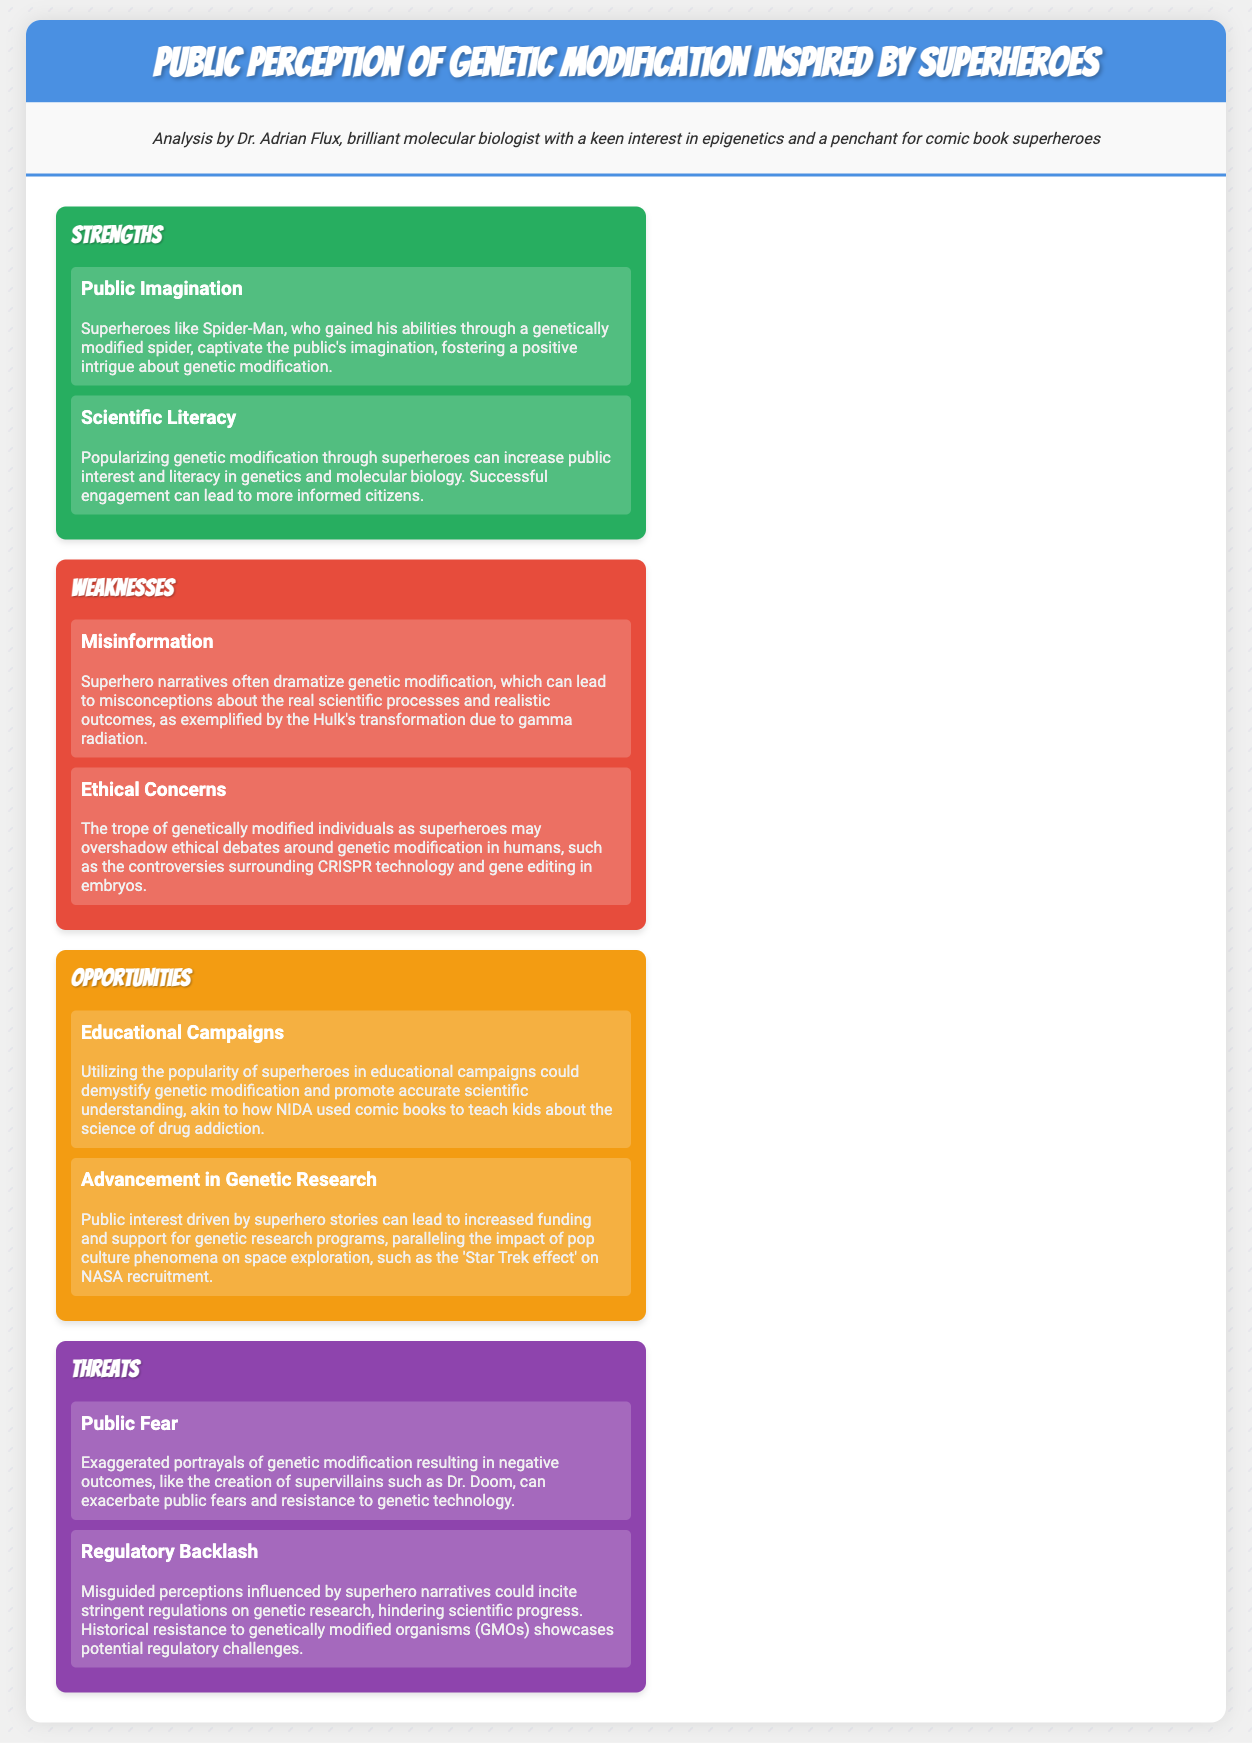What are the strengths highlighted in the analysis? The strengths are the aspects of the SWOT analysis that emphasize positive factors related to public perception of genetic modification. The document identifies "Public Imagination" and "Scientific Literacy" as strengths.
Answer: Public Imagination, Scientific Literacy What superhero is mentioned in the strengths section? The mention of Spider-Man in the strengths section highlights a superhero that influences public perception positively.
Answer: Spider-Man What are the weaknesses identified in the analysis? The weaknesses are detrimental aspects related to public perception of genetic modification. The document states "Misinformation" and "Ethical Concerns" as weaknesses.
Answer: Misinformation, Ethical Concerns What opportunity is suggested concerning educational campaigns? The document proposes that utilizing superhero popularity in campaigns could help clarify genetic modification. This is an example of the potential opportunities noted.
Answer: Educational Campaigns What threat is associated with public fear according to the analysis? The analysis suggests that exaggerated portrayals of genetic modification lead to public fears, which is a critical aspect of the threats identified.
Answer: Public Fear What does “Regulatory Backlash” refer to in the threats? This term in the document relates to misguided perceptions based on superhero narratives that could impact regulations on genetic research.
Answer: Regulatory Backlash How can superhero narratives impact funding for genetic research? The analysis notes that public interest from superhero stories could lead to increased funding and support for genetic research programs.
Answer: Advancement in Genetic Research Which comic book approach is mentioned as an example for educational techniques? The document references NIDA using comic books to teach about drug addiction as a successful method that could be mirrored in genetic modification education.
Answer: NIDA What theme is suggested regarding ethical concerns? Ethical concerns around genetic modification in humans are highlighted as an aspect that may be overshadowed by superhero narratives.
Answer: Ethical Concerns 